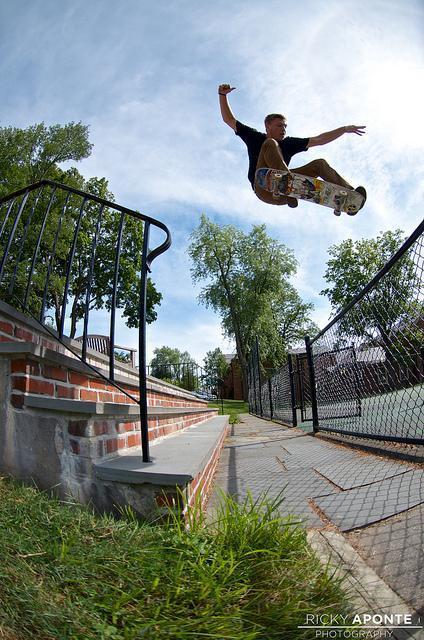How many steps are there?
Give a very brief answer. 4. How many people are visible?
Give a very brief answer. 1. How many open umbrellas are there?
Give a very brief answer. 0. 